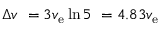Convert formula to latex. <formula><loc_0><loc_0><loc_500><loc_500>\Delta v \ = 3 v _ { e } \ln 5 \ = 4 . 8 3 v _ { e }</formula> 